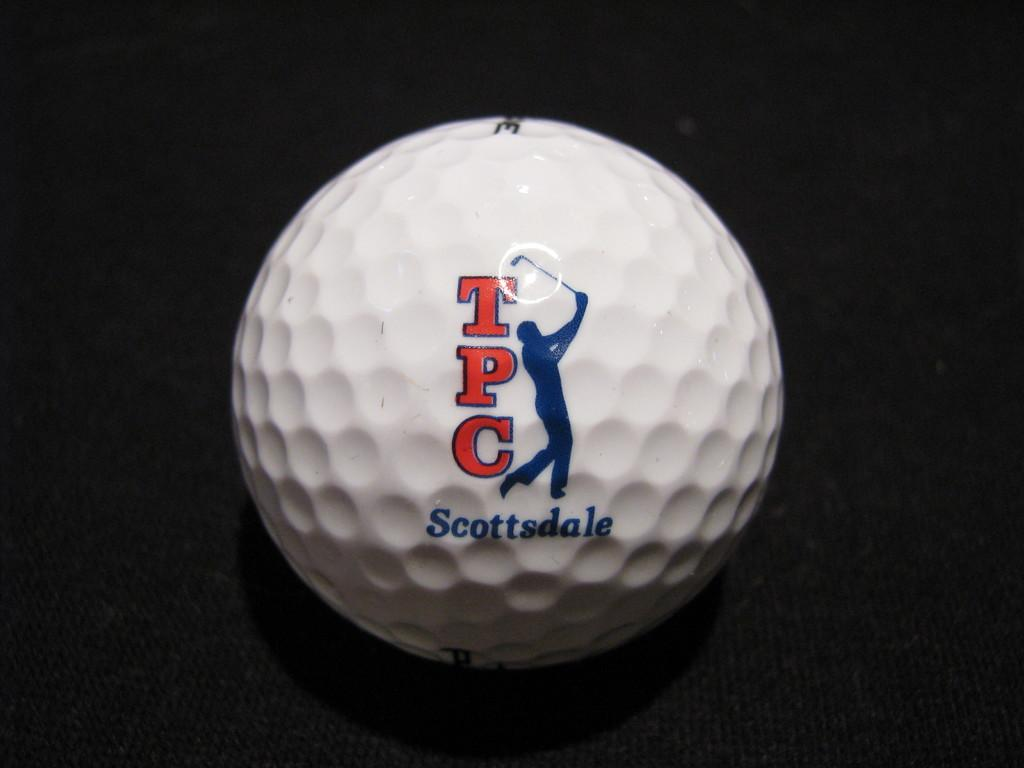<image>
Describe the image concisely. A closeup of a golf ball with TPC Scottsdale imprinted on it is shown. 